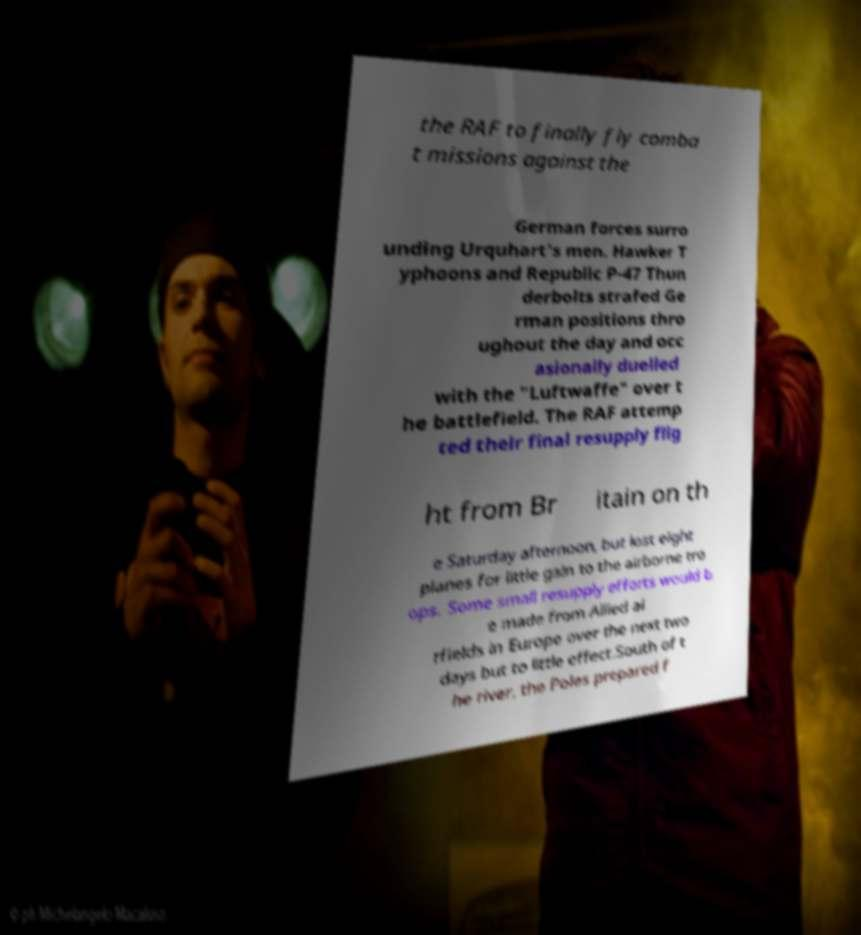There's text embedded in this image that I need extracted. Can you transcribe it verbatim? the RAF to finally fly comba t missions against the German forces surro unding Urquhart's men. Hawker T yphoons and Republic P-47 Thun derbolts strafed Ge rman positions thro ughout the day and occ asionally duelled with the "Luftwaffe" over t he battlefield. The RAF attemp ted their final resupply flig ht from Br itain on th e Saturday afternoon, but lost eight planes for little gain to the airborne tro ops. Some small resupply efforts would b e made from Allied ai rfields in Europe over the next two days but to little effect.South of t he river, the Poles prepared f 